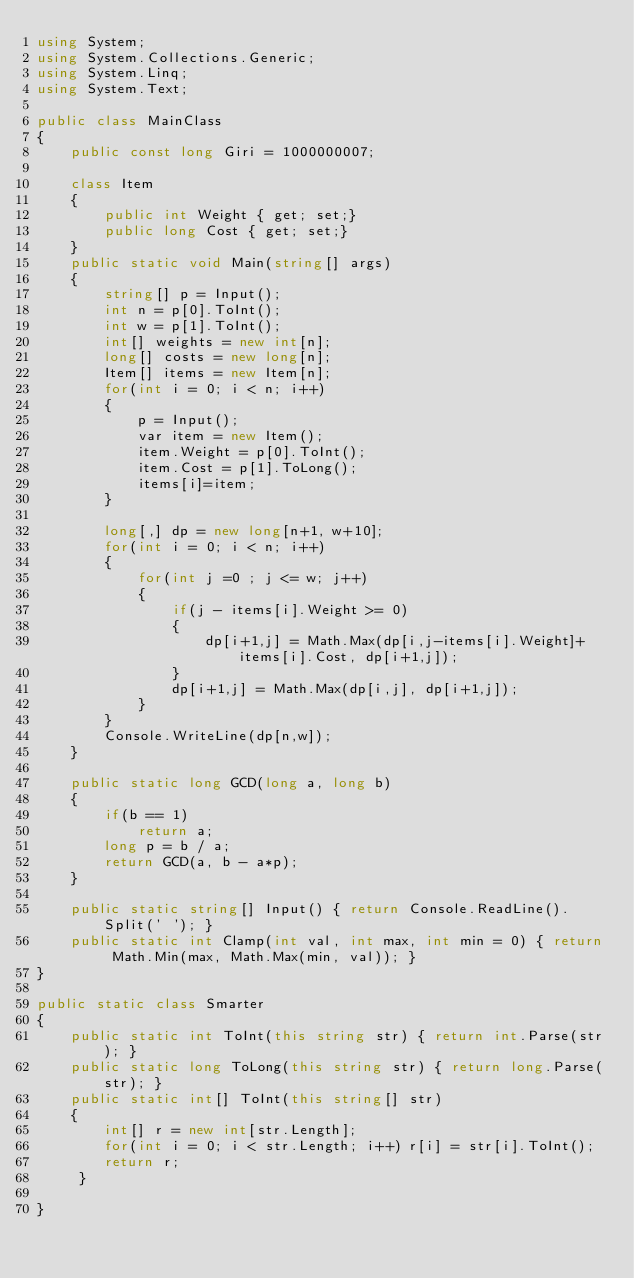<code> <loc_0><loc_0><loc_500><loc_500><_C#_>using System;
using System.Collections.Generic;
using System.Linq;
using System.Text;

public class MainClass
{
	public const long Giri = 1000000007;
	
	class Item
	{
		public int Weight { get; set;}
		public long Cost { get; set;}
	}
	public static void Main(string[] args)
	{
		string[] p = Input();
		int n = p[0].ToInt();
		int w = p[1].ToInt();
		int[] weights = new int[n];
		long[] costs = new long[n];
		Item[] items = new Item[n];
		for(int i = 0; i < n; i++)
		{
			p = Input();
			var item = new Item();
			item.Weight = p[0].ToInt();
			item.Cost = p[1].ToLong();
			items[i]=item;
		}
		
		long[,] dp = new long[n+1, w+10];
		for(int i = 0; i < n; i++)
		{
			for(int j =0 ; j <= w; j++)
			{
				if(j - items[i].Weight >= 0)
				{
					dp[i+1,j] = Math.Max(dp[i,j-items[i].Weight]+items[i].Cost, dp[i+1,j]);
				}
				dp[i+1,j] = Math.Max(dp[i,j], dp[i+1,j]);
			}
		}
		Console.WriteLine(dp[n,w]);
	}
	
	public static long GCD(long a, long b)
	{
		if(b == 1)
			return a;
		long p = b / a;
		return GCD(a, b - a*p);
	}
	
	public static string[] Input() { return Console.ReadLine().Split(' '); }
	public static int Clamp(int val, int max, int min = 0) { return Math.Min(max, Math.Max(min, val)); }
}

public static class Smarter
{
	public static int ToInt(this string str) { return int.Parse(str); }
	public static long ToLong(this string str) { return long.Parse(str); }
	public static int[] ToInt(this string[] str)
	{
		int[] r = new int[str.Length];
		for(int i = 0; i < str.Length; i++) r[i] = str[i].ToInt();
		return r;
	 }
	
}</code> 